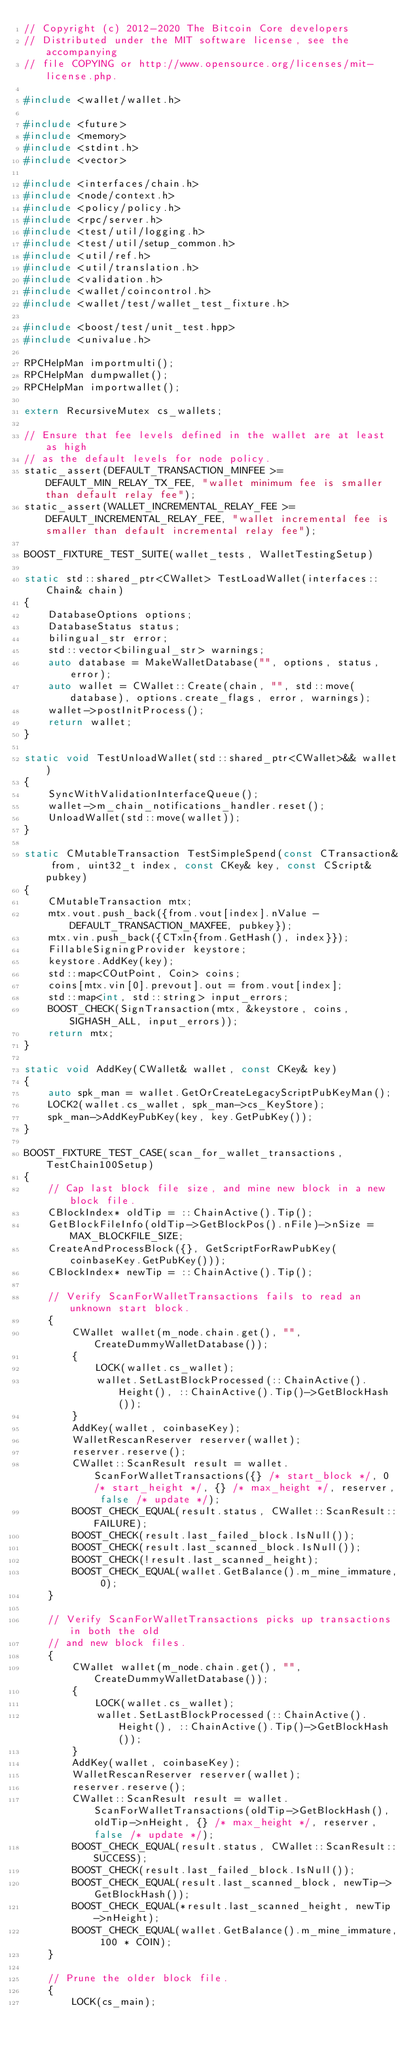Convert code to text. <code><loc_0><loc_0><loc_500><loc_500><_C++_>// Copyright (c) 2012-2020 The Bitcoin Core developers
// Distributed under the MIT software license, see the accompanying
// file COPYING or http://www.opensource.org/licenses/mit-license.php.

#include <wallet/wallet.h>

#include <future>
#include <memory>
#include <stdint.h>
#include <vector>

#include <interfaces/chain.h>
#include <node/context.h>
#include <policy/policy.h>
#include <rpc/server.h>
#include <test/util/logging.h>
#include <test/util/setup_common.h>
#include <util/ref.h>
#include <util/translation.h>
#include <validation.h>
#include <wallet/coincontrol.h>
#include <wallet/test/wallet_test_fixture.h>

#include <boost/test/unit_test.hpp>
#include <univalue.h>

RPCHelpMan importmulti();
RPCHelpMan dumpwallet();
RPCHelpMan importwallet();

extern RecursiveMutex cs_wallets;

// Ensure that fee levels defined in the wallet are at least as high
// as the default levels for node policy.
static_assert(DEFAULT_TRANSACTION_MINFEE >= DEFAULT_MIN_RELAY_TX_FEE, "wallet minimum fee is smaller than default relay fee");
static_assert(WALLET_INCREMENTAL_RELAY_FEE >= DEFAULT_INCREMENTAL_RELAY_FEE, "wallet incremental fee is smaller than default incremental relay fee");

BOOST_FIXTURE_TEST_SUITE(wallet_tests, WalletTestingSetup)

static std::shared_ptr<CWallet> TestLoadWallet(interfaces::Chain& chain)
{
    DatabaseOptions options;
    DatabaseStatus status;
    bilingual_str error;
    std::vector<bilingual_str> warnings;
    auto database = MakeWalletDatabase("", options, status, error);
    auto wallet = CWallet::Create(chain, "", std::move(database), options.create_flags, error, warnings);
    wallet->postInitProcess();
    return wallet;
}

static void TestUnloadWallet(std::shared_ptr<CWallet>&& wallet)
{
    SyncWithValidationInterfaceQueue();
    wallet->m_chain_notifications_handler.reset();
    UnloadWallet(std::move(wallet));
}

static CMutableTransaction TestSimpleSpend(const CTransaction& from, uint32_t index, const CKey& key, const CScript& pubkey)
{
    CMutableTransaction mtx;
    mtx.vout.push_back({from.vout[index].nValue - DEFAULT_TRANSACTION_MAXFEE, pubkey});
    mtx.vin.push_back({CTxIn{from.GetHash(), index}});
    FillableSigningProvider keystore;
    keystore.AddKey(key);
    std::map<COutPoint, Coin> coins;
    coins[mtx.vin[0].prevout].out = from.vout[index];
    std::map<int, std::string> input_errors;
    BOOST_CHECK(SignTransaction(mtx, &keystore, coins, SIGHASH_ALL, input_errors));
    return mtx;
}

static void AddKey(CWallet& wallet, const CKey& key)
{
    auto spk_man = wallet.GetOrCreateLegacyScriptPubKeyMan();
    LOCK2(wallet.cs_wallet, spk_man->cs_KeyStore);
    spk_man->AddKeyPubKey(key, key.GetPubKey());
}

BOOST_FIXTURE_TEST_CASE(scan_for_wallet_transactions, TestChain100Setup)
{
    // Cap last block file size, and mine new block in a new block file.
    CBlockIndex* oldTip = ::ChainActive().Tip();
    GetBlockFileInfo(oldTip->GetBlockPos().nFile)->nSize = MAX_BLOCKFILE_SIZE;
    CreateAndProcessBlock({}, GetScriptForRawPubKey(coinbaseKey.GetPubKey()));
    CBlockIndex* newTip = ::ChainActive().Tip();

    // Verify ScanForWalletTransactions fails to read an unknown start block.
    {
        CWallet wallet(m_node.chain.get(), "", CreateDummyWalletDatabase());
        {
            LOCK(wallet.cs_wallet);
            wallet.SetLastBlockProcessed(::ChainActive().Height(), ::ChainActive().Tip()->GetBlockHash());
        }
        AddKey(wallet, coinbaseKey);
        WalletRescanReserver reserver(wallet);
        reserver.reserve();
        CWallet::ScanResult result = wallet.ScanForWalletTransactions({} /* start_block */, 0 /* start_height */, {} /* max_height */, reserver, false /* update */);
        BOOST_CHECK_EQUAL(result.status, CWallet::ScanResult::FAILURE);
        BOOST_CHECK(result.last_failed_block.IsNull());
        BOOST_CHECK(result.last_scanned_block.IsNull());
        BOOST_CHECK(!result.last_scanned_height);
        BOOST_CHECK_EQUAL(wallet.GetBalance().m_mine_immature, 0);
    }

    // Verify ScanForWalletTransactions picks up transactions in both the old
    // and new block files.
    {
        CWallet wallet(m_node.chain.get(), "", CreateDummyWalletDatabase());
        {
            LOCK(wallet.cs_wallet);
            wallet.SetLastBlockProcessed(::ChainActive().Height(), ::ChainActive().Tip()->GetBlockHash());
        }
        AddKey(wallet, coinbaseKey);
        WalletRescanReserver reserver(wallet);
        reserver.reserve();
        CWallet::ScanResult result = wallet.ScanForWalletTransactions(oldTip->GetBlockHash(), oldTip->nHeight, {} /* max_height */, reserver, false /* update */);
        BOOST_CHECK_EQUAL(result.status, CWallet::ScanResult::SUCCESS);
        BOOST_CHECK(result.last_failed_block.IsNull());
        BOOST_CHECK_EQUAL(result.last_scanned_block, newTip->GetBlockHash());
        BOOST_CHECK_EQUAL(*result.last_scanned_height, newTip->nHeight);
        BOOST_CHECK_EQUAL(wallet.GetBalance().m_mine_immature, 100 * COIN);
    }

    // Prune the older block file.
    {
        LOCK(cs_main);</code> 